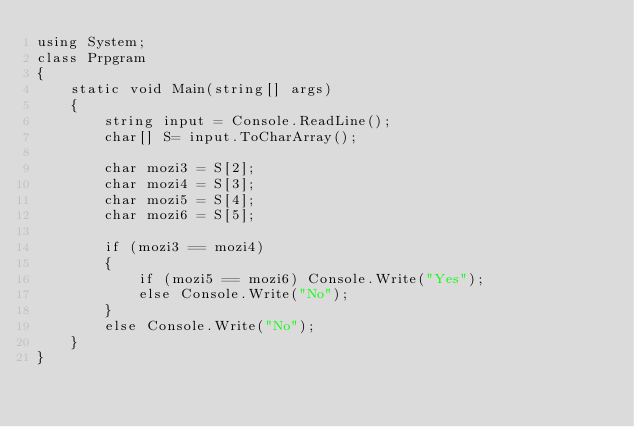<code> <loc_0><loc_0><loc_500><loc_500><_C#_>using System;
class Prpgram
{
    static void Main(string[] args)
    {
        string input = Console.ReadLine();
        char[] S= input.ToCharArray();

        char mozi3 = S[2];
        char mozi4 = S[3];
        char mozi5 = S[4];
        char mozi6 = S[5];

        if (mozi3 == mozi4)
        {
            if (mozi5 == mozi6) Console.Write("Yes");
            else Console.Write("No");
        }
        else Console.Write("No");
    }
}</code> 